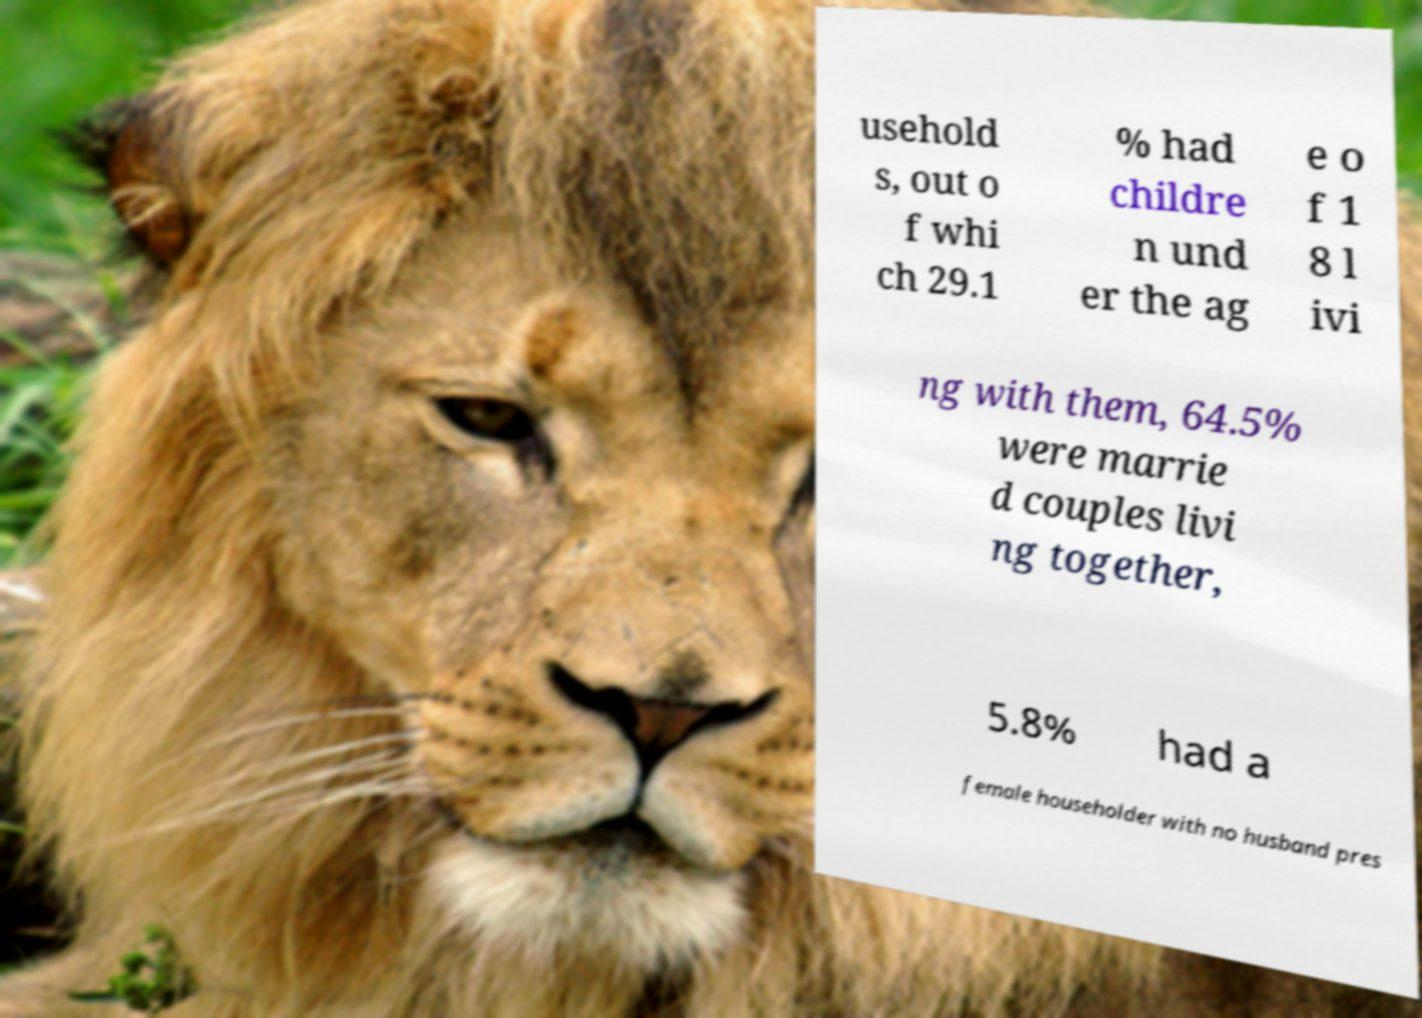Could you extract and type out the text from this image? usehold s, out o f whi ch 29.1 % had childre n und er the ag e o f 1 8 l ivi ng with them, 64.5% were marrie d couples livi ng together, 5.8% had a female householder with no husband pres 